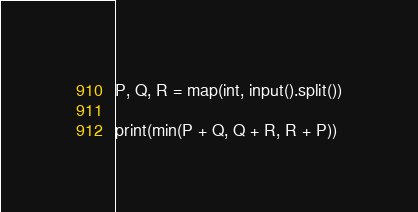Convert code to text. <code><loc_0><loc_0><loc_500><loc_500><_Python_>P, Q, R = map(int, input().split())

print(min(P + Q, Q + R, R + P))
</code> 